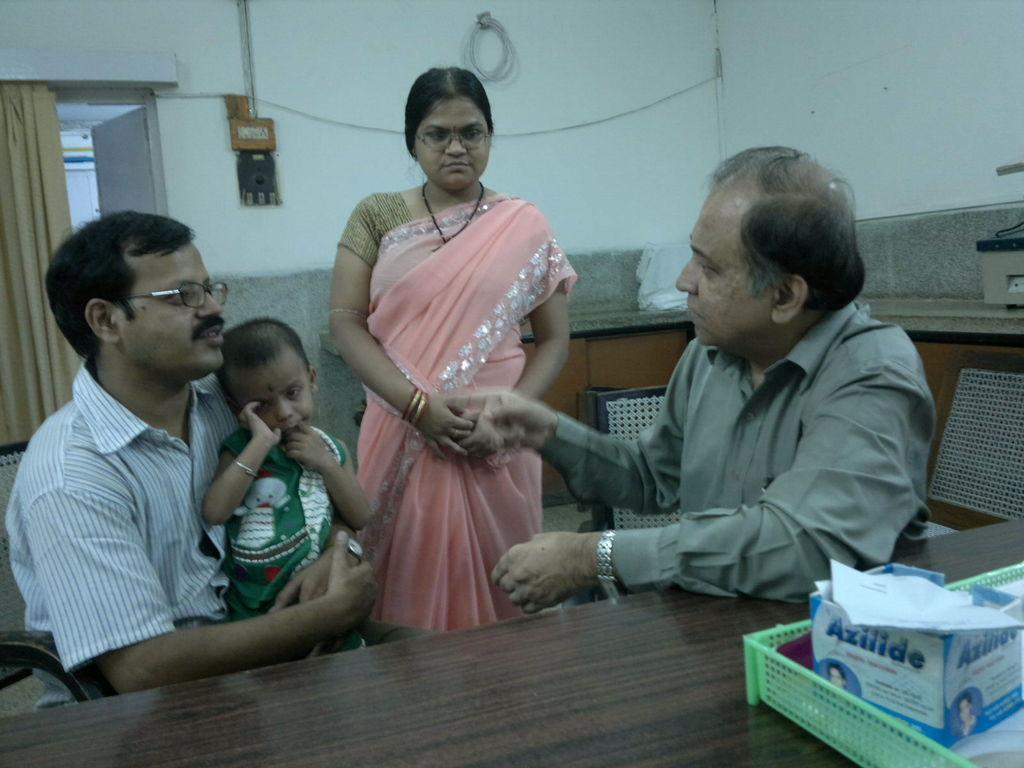Can you describe this image briefly? There are two men sitting on chairs and this man holding baby and this woman standing and we can see tray and box on table. On the background we can see objects on shelf,wall,switch board,curtain and door. 